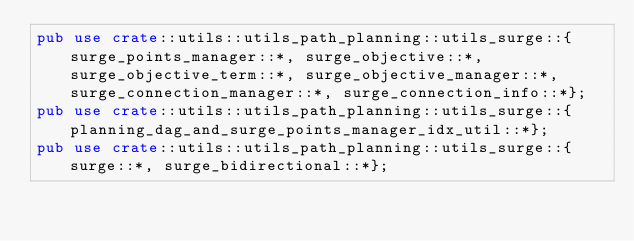Convert code to text. <code><loc_0><loc_0><loc_500><loc_500><_Rust_>pub use crate::utils::utils_path_planning::utils_surge::{surge_points_manager::*, surge_objective::*, surge_objective_term::*, surge_objective_manager::*, surge_connection_manager::*, surge_connection_info::*};
pub use crate::utils::utils_path_planning::utils_surge::{planning_dag_and_surge_points_manager_idx_util::*};
pub use crate::utils::utils_path_planning::utils_surge::{surge::*, surge_bidirectional::*};</code> 